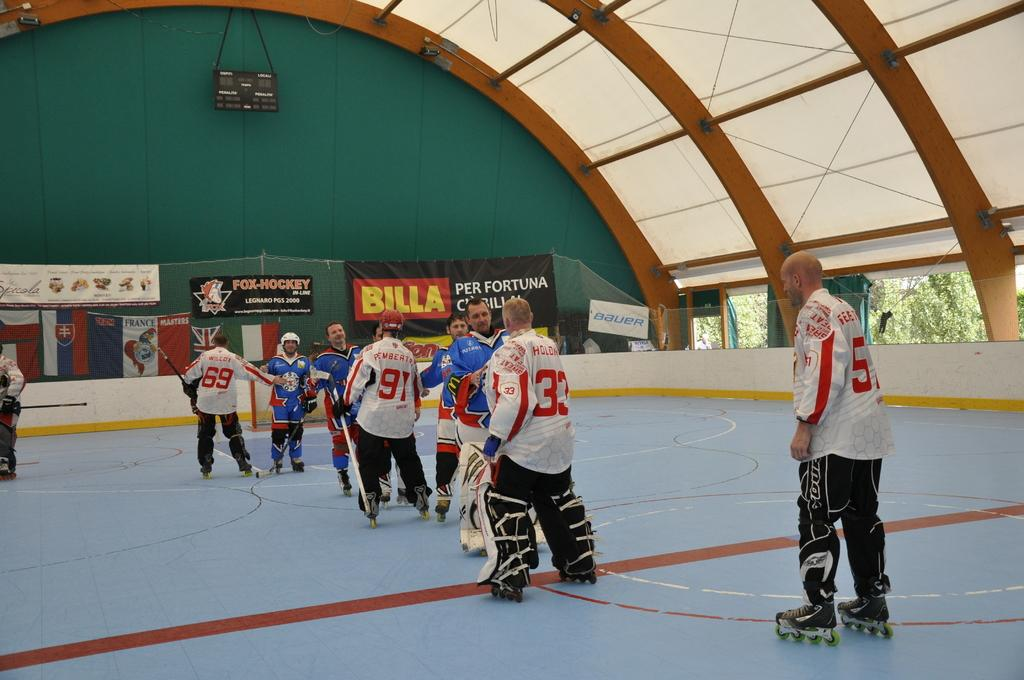<image>
Create a compact narrative representing the image presented. A BILLA advertisement is on the wall in a hockey arena. 